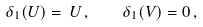Convert formula to latex. <formula><loc_0><loc_0><loc_500><loc_500>\delta _ { 1 } ( U ) = \, U \, , \quad \delta _ { 1 } ( V ) = 0 \, ,</formula> 